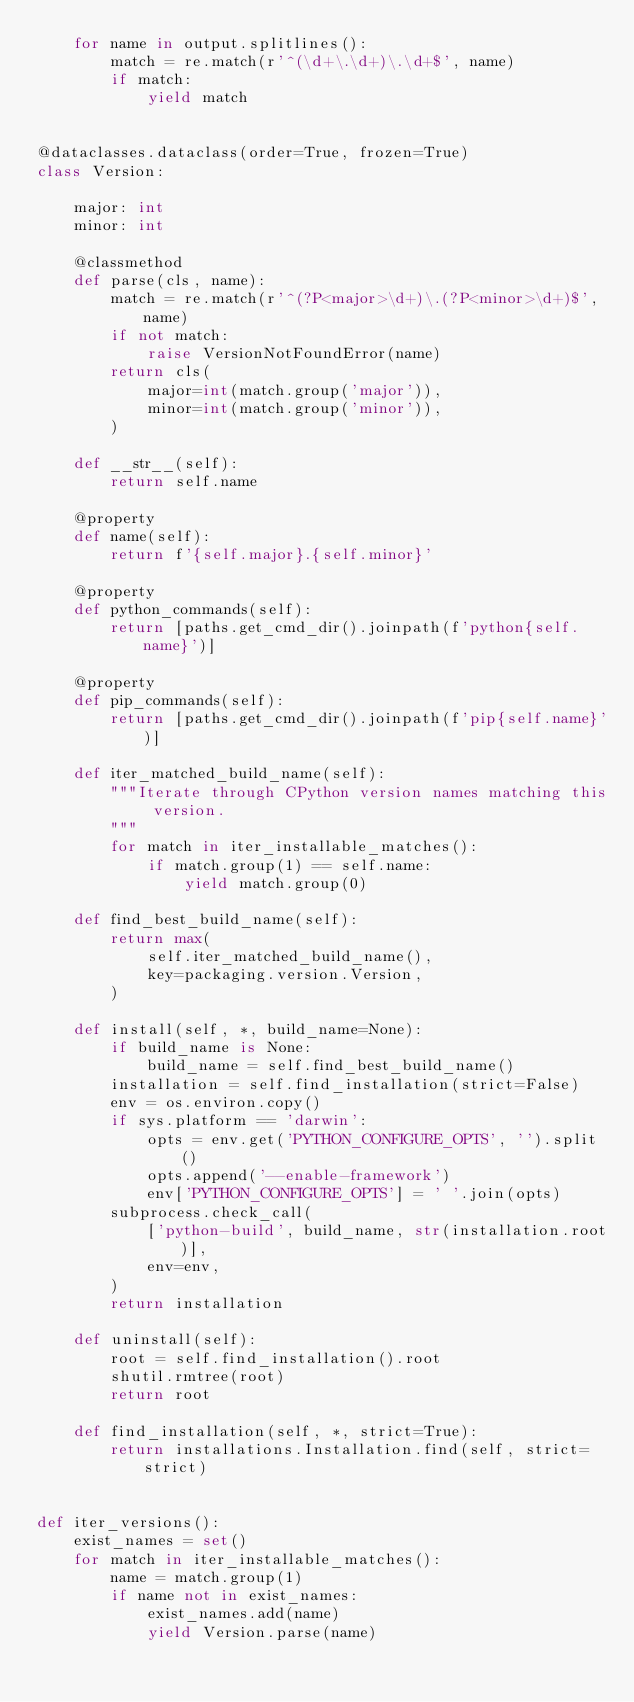<code> <loc_0><loc_0><loc_500><loc_500><_Python_>    for name in output.splitlines():
        match = re.match(r'^(\d+\.\d+)\.\d+$', name)
        if match:
            yield match


@dataclasses.dataclass(order=True, frozen=True)
class Version:

    major: int
    minor: int

    @classmethod
    def parse(cls, name):
        match = re.match(r'^(?P<major>\d+)\.(?P<minor>\d+)$', name)
        if not match:
            raise VersionNotFoundError(name)
        return cls(
            major=int(match.group('major')),
            minor=int(match.group('minor')),
        )

    def __str__(self):
        return self.name

    @property
    def name(self):
        return f'{self.major}.{self.minor}'

    @property
    def python_commands(self):
        return [paths.get_cmd_dir().joinpath(f'python{self.name}')]

    @property
    def pip_commands(self):
        return [paths.get_cmd_dir().joinpath(f'pip{self.name}')]

    def iter_matched_build_name(self):
        """Iterate through CPython version names matching this version.
        """
        for match in iter_installable_matches():
            if match.group(1) == self.name:
                yield match.group(0)

    def find_best_build_name(self):
        return max(
            self.iter_matched_build_name(),
            key=packaging.version.Version,
        )

    def install(self, *, build_name=None):
        if build_name is None:
            build_name = self.find_best_build_name()
        installation = self.find_installation(strict=False)
        env = os.environ.copy()
        if sys.platform == 'darwin':
            opts = env.get('PYTHON_CONFIGURE_OPTS', '').split()
            opts.append('--enable-framework')
            env['PYTHON_CONFIGURE_OPTS'] = ' '.join(opts)
        subprocess.check_call(
            ['python-build', build_name, str(installation.root)],
            env=env,
        )
        return installation

    def uninstall(self):
        root = self.find_installation().root
        shutil.rmtree(root)
        return root

    def find_installation(self, *, strict=True):
        return installations.Installation.find(self, strict=strict)


def iter_versions():
    exist_names = set()
    for match in iter_installable_matches():
        name = match.group(1)
        if name not in exist_names:
            exist_names.add(name)
            yield Version.parse(name)
</code> 